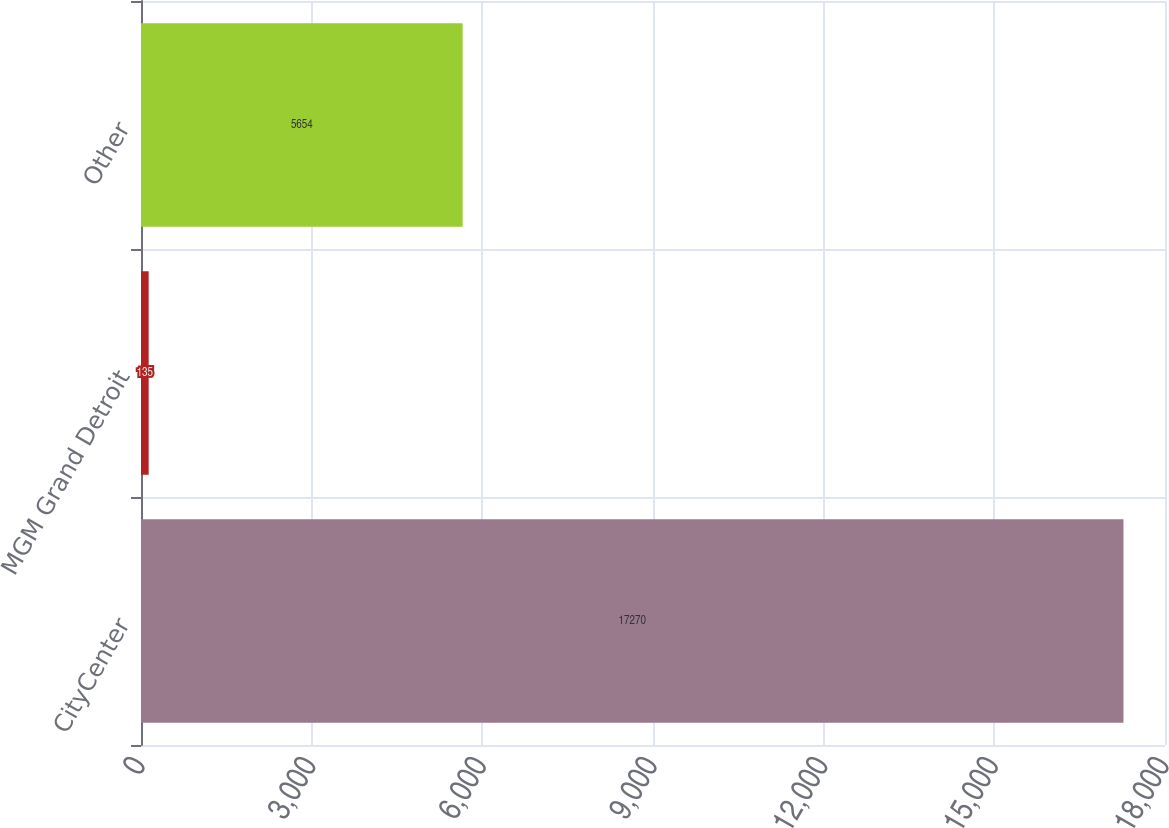<chart> <loc_0><loc_0><loc_500><loc_500><bar_chart><fcel>CityCenter<fcel>MGM Grand Detroit<fcel>Other<nl><fcel>17270<fcel>135<fcel>5654<nl></chart> 